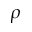<formula> <loc_0><loc_0><loc_500><loc_500>\rho</formula> 